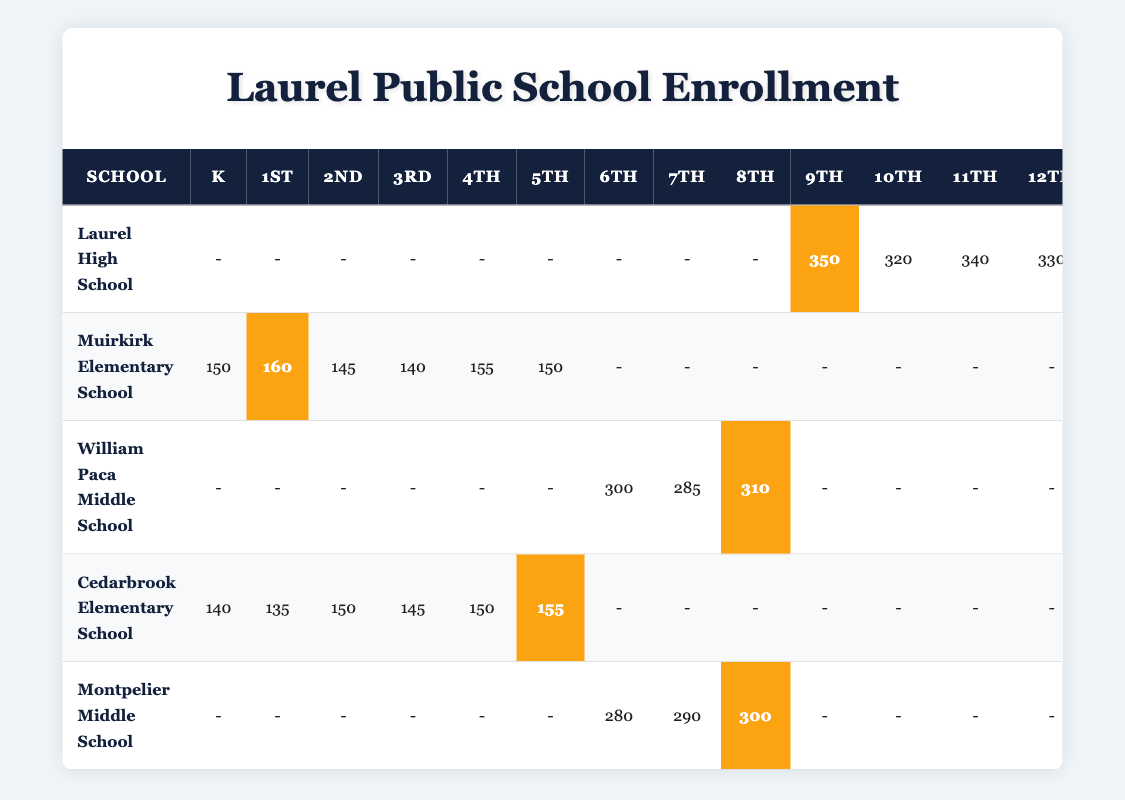What is the total enrollment for kindergarten at both elementary schools? The enrollments for kindergarten are 150 at Muirkirk Elementary School and 140 at Cedarbrook Elementary School. Adding these together gives 150 + 140 = 290 total enrollments for kindergarten.
Answer: 290 Which middle school has the highest enrollment in the 8th grade? The enrollment for 8th grade is 310 at William Paca Middle School and 300 at Montpelier Middle School. William Paca has the higher enrollment.
Answer: William Paca Middle School What is the average enrollment for 10th grade across all schools? The only schools listing 10th grade enrollment are Laurel High School with 320 students. Since it's the only data point, the average is simply 320.
Answer: 320 Is Muirkirk Elementary School's 1st grade enrollment higher than Cedarbrook Elementary School's 1st grade enrollment? Muirkirk has 160 students in 1st grade, while Cedarbrook has 135. Since 160 > 135, Muirkirk's 1st grade enrollment is indeed higher.
Answer: Yes What is the total enrollment for all grade levels combined at Laurel High School? To find this, add the enrollments for each grade: 350 (9th) + 320 (10th) + 340 (11th) + 330 (12th) = 1,340 total.
Answer: 1340 Calculate the difference in 6th grade enrollment between William Paca Middle School and Montpelier Middle School. William Paca has 300 students in 6th grade, while Montpelier has 280. The difference is 300 - 280 = 20.
Answer: 20 What is the sum of the 5th grade enrollments from both elementary schools? At Muirkirk, 150 students are enrolled in 5th grade, and at Cedarbrook, there are 155 students. The total is 150 + 155 = 305.
Answer: 305 Which grade has the highest enrollment in the schools listed? At Laurel High School, 9th grade has 350 students, while the highest at elementary or middle school levels is 310 in 8th grade at William Paca. Thus, 9th grade has the highest enrollment overall.
Answer: 9th grade Does any school have a 12th grade enrollment lower than 330? Laurel High School has 330 students in 12th grade, and since it’s the only school listed with a 12th grade, the comparison does not yield a lower number.
Answer: No Find the total enrollment for 3rd grade across both elementary schools. Muirkirk has 140 students and Cedarbrook has 145 students in 3rd grade. The total enrollment is 140 + 145 = 285.
Answer: 285 